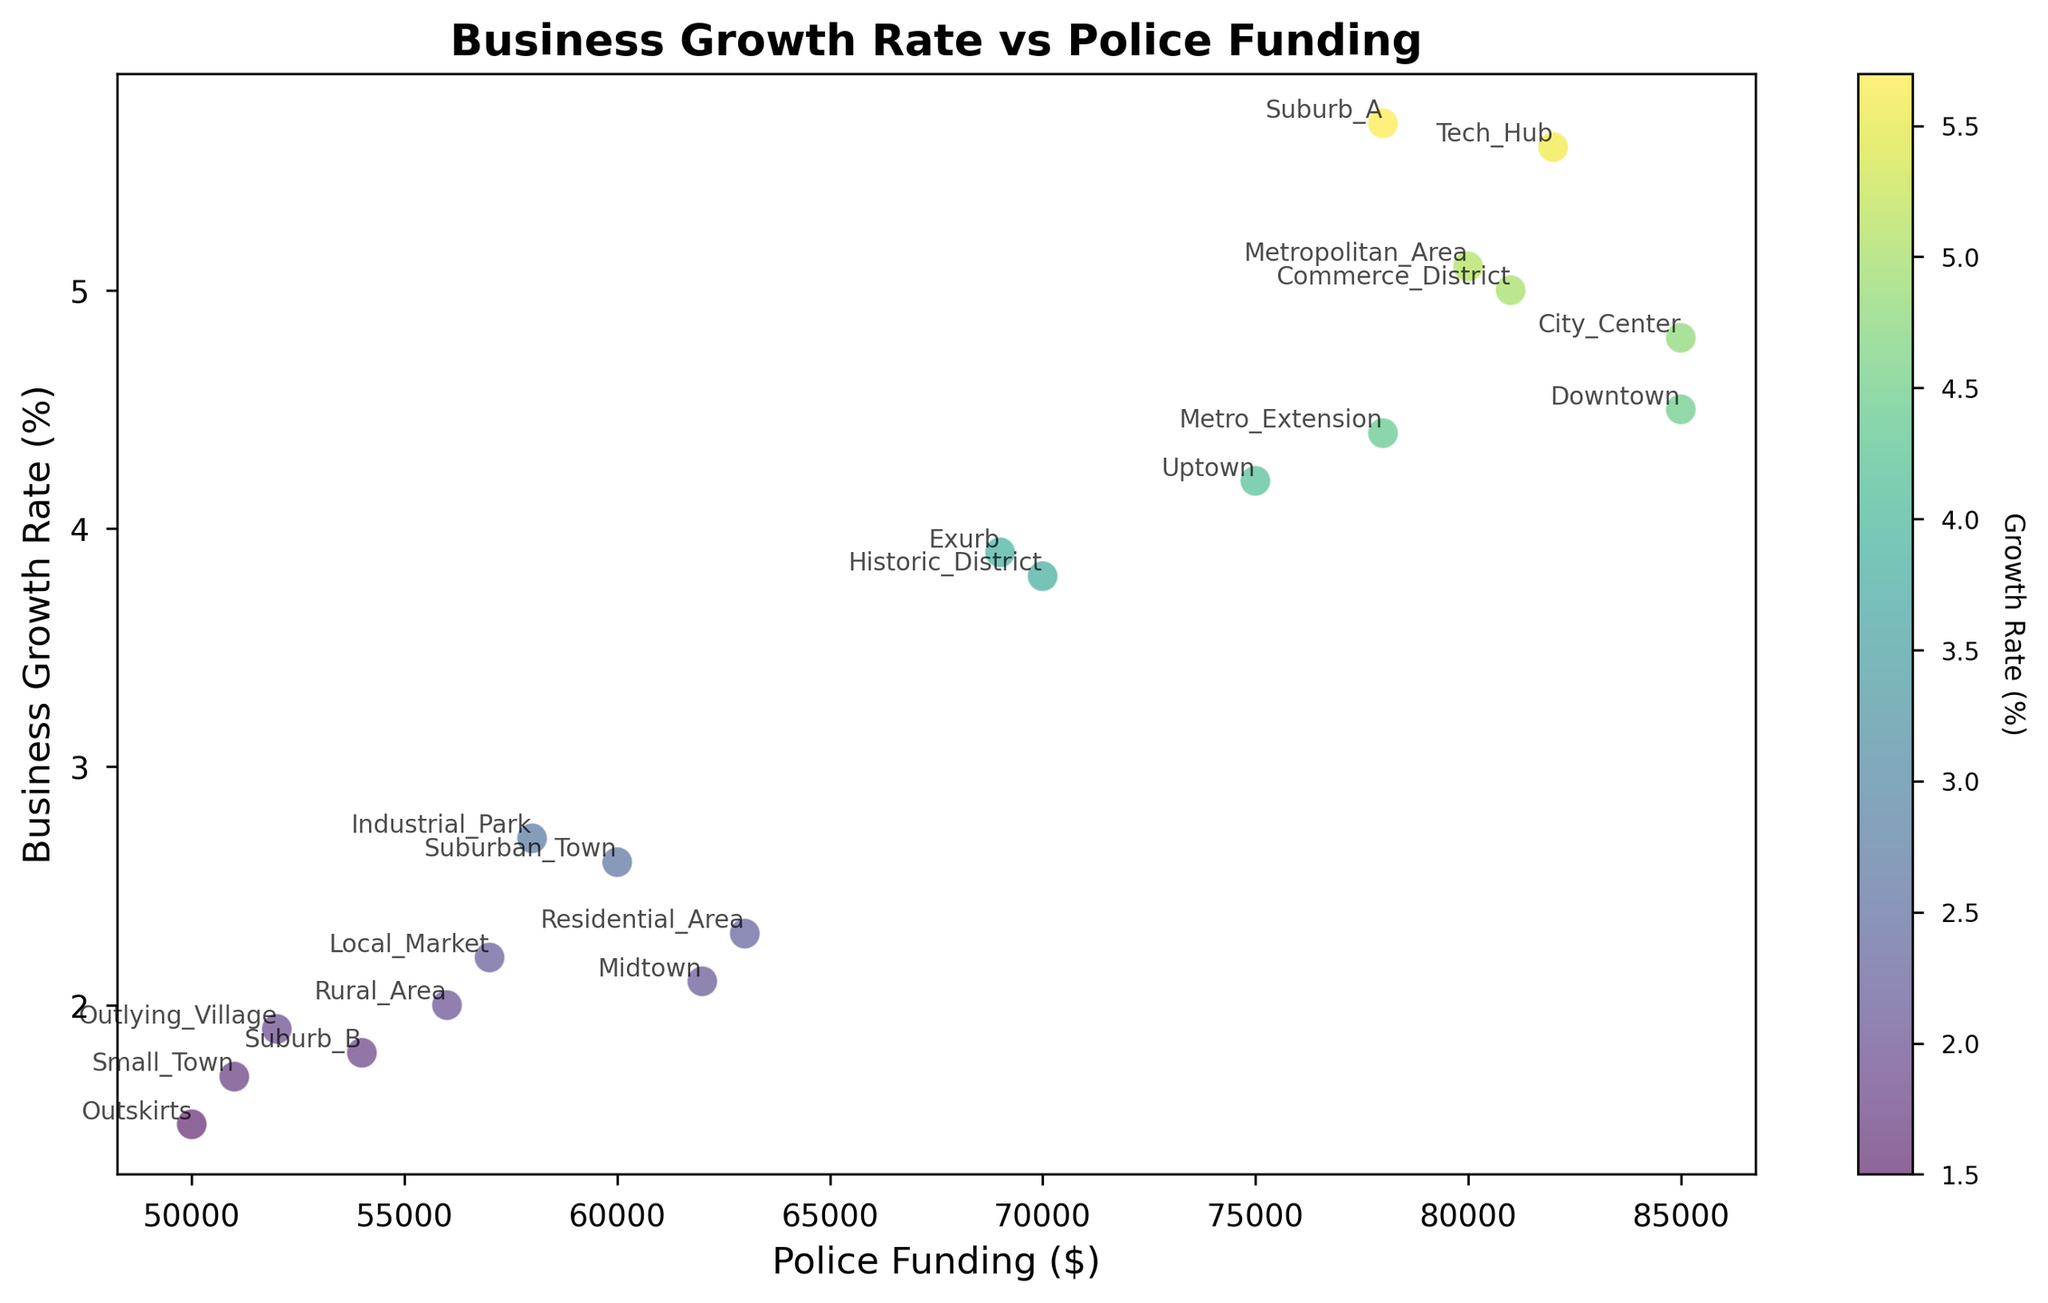What is the business growth rate for the area with the highest police funding? The ‘Downtown’ area has the highest police funding at $85,000. By looking at the plot, we observe that the business growth rate for ‘Downtown’ is 4.5%.
Answer: 4.5% Which area has the lowest business growth rate and what is its corresponding police funding? By inspecting the lowest point on the vertical axis (Business Growth Rate), we find that ‘Outskirts’ has the lowest growth rate which is 1.5%. The police funding for this area is $50,000.
Answer: Outskirts, $50,000 Is there an area with high police funding but low business growth rate? If yes, name it and provide the exact values. By observing areas with police funding above $70,000, we notice that most areas have high business growth rates. However, ‘Metropolitan_Area’ stands out with $80,000 in police funding but relatively low business growth rate at 5.1%.
Answer: Metropolitan_Area, business growth rate 5.1%, police funding $80,000 What is the average police funding for areas with a business growth rate higher than 4%? Areas with business growth rates higher than 4% are Downtown, Suburb_A, Uptown, City_Center, Tech_Hub, Commerce_District, and Metro_Extension. Their police fundings are $85,000, $78,000, $75,000, $85,000, $82,000, $81,000, and $78,000 respectively. The sum of these values is $564,000 and dividing by 7 gives an average of $80,571.43.
Answer: $80,571.43 Which areas have police funding closest to the average value of police funding for all areas and what are their business growth rates? To find the average police funding, sum all the police funding values and divide by the number of areas. The total police funding is $1,310,000 divided by 20 areas results in an average funding of $65,500. The closest values are Midtown ($62,000, Growth 2.1%), Exurb ($69,000, Growth 3.9%), and Residential_Area ($63,000, Growth 2.3%).
Answer: Midtown (2.1%), Exurb (3.9%), Residential_Area (2.3%) Compare the business growth rates of areas with police funding above $70,000 and below $70,000. Which group generally has higher growth rates? By analyzing the scatter plot, the areas with police funding above $70,000 (Downtown, Suburb_A, Uptown, City_Center, Tech_Hub, Commerce_District, Metro_Extension) mostly have business growth rates above 4%. For police funding below $70,000 (Midtown, Suburb_B, Exurb, Industrial_Park, Outskirts, Rural_Area, Residential_Area, Local_Market and others) have growth rates below 4% generally. Therefore, areas with police funding above $70,000 generally have higher growth rates.
Answer: Above $70,000 Does an area with high business growth rate necessarily have high police funding? The scatter plot shows that areas with high business growth rates (above 5%; Suburb_A, Tech_Hub, Commerce_District) generally have high police funding (above $70,000). Thus, higher police funding correlates with higher business growth rates in this dataset.
Answer: Yes, generally What is the overall trend between police funding and business growth rate visible in the scatter plot? By looking at the scatter plot, a positive trend can be observed where as police funding increases, the business growth rate also tends to increase. Areas with higher police funding majorly show higher business growth rates as compared to areas with lower police funding.
Answer: Positive trend 